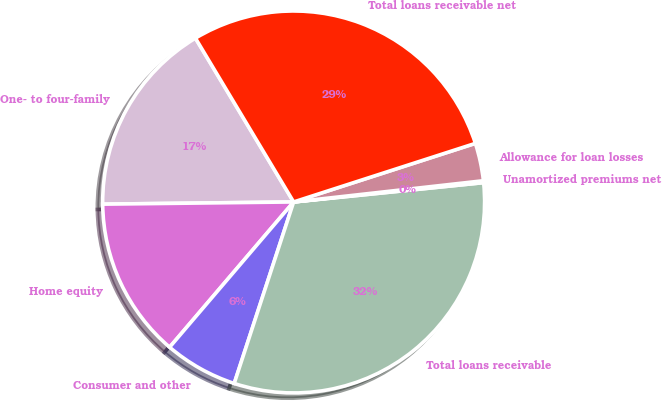Convert chart. <chart><loc_0><loc_0><loc_500><loc_500><pie_chart><fcel>One- to four-family<fcel>Home equity<fcel>Consumer and other<fcel>Total loans receivable<fcel>Unamortized premiums net<fcel>Allowance for loan losses<fcel>Total loans receivable net<nl><fcel>16.59%<fcel>13.57%<fcel>6.21%<fcel>31.65%<fcel>0.16%<fcel>3.19%<fcel>28.63%<nl></chart> 